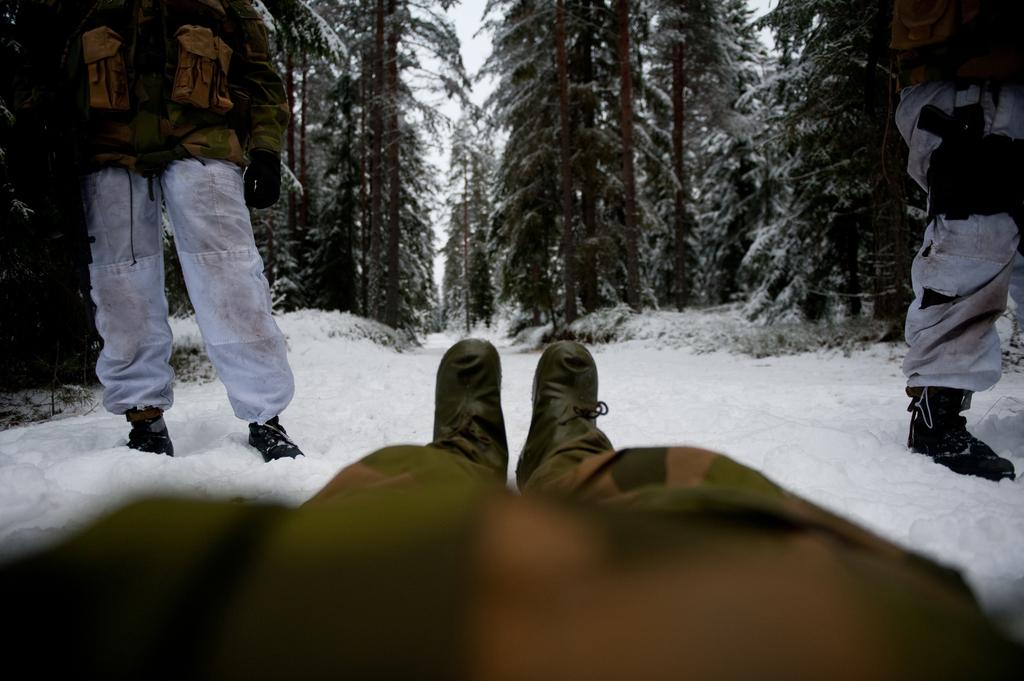What is the main subject of the image? There is a person lying on the snow in the image. Are there any other people in the image? Yes, there are two people standing in front of the lying person. What can be seen in the background of the image? There are trees and the sky visible in the background of the image. What type of ear is visible on the person lying on the snow? There is no ear visible on the person lying on the snow in the image. What message are the two standing people saying good-bye to the person lying on the snow? There is no indication in the image that the two standing people are saying good-bye to the person lying on the snow. 